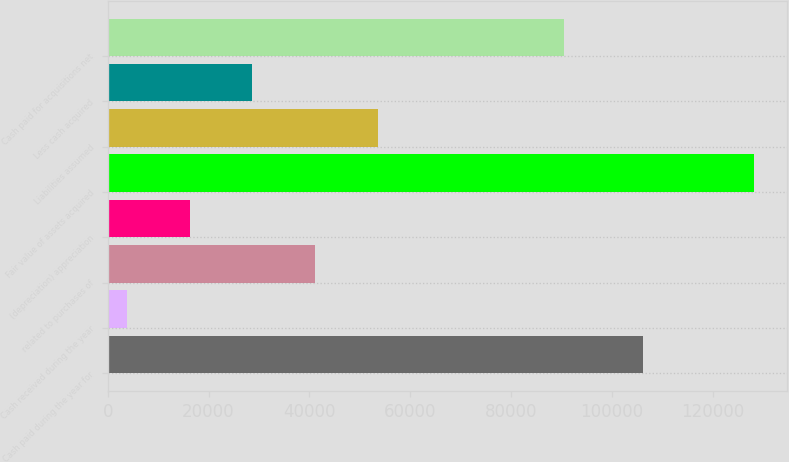Convert chart. <chart><loc_0><loc_0><loc_500><loc_500><bar_chart><fcel>Cash paid during the year for<fcel>Cash received during the year<fcel>related to purchases of<fcel>(depreciation) appreciation<fcel>Fair value of assets acquired<fcel>Liabilities assumed<fcel>Less cash acquired<fcel>Cash paid for acquisitions net<nl><fcel>106146<fcel>3806<fcel>41121.2<fcel>16244.4<fcel>128190<fcel>53559.6<fcel>28682.8<fcel>90471<nl></chart> 